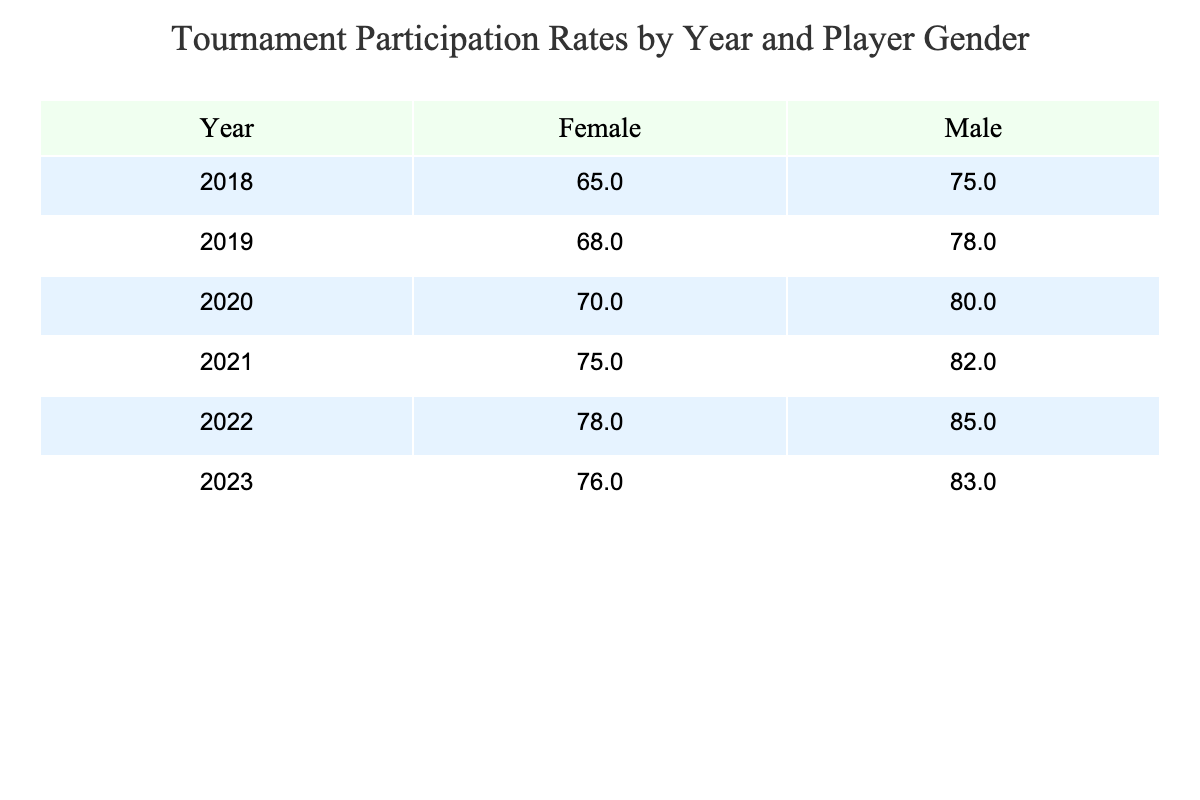What was the tournament participation rate for males in 2022? In the table, look at the row for 2022 and locate the value under the "Male" column. The participation rate for males in 2022 is 85%.
Answer: 85% What was the tournament participation rate for females in 2019? To find the answer, check the row for 2019 and look under the "Female" column. The value there indicates a participation rate of 68% for females in 2019.
Answer: 68% What is the average tournament participation rate for males from 2018 to 2023? First, gather the male participation rates from each year: 75%, 78%, 80%, 82%, 85%, and 83%. Then, sum these values: 75 + 78 + 80 + 82 + 85 + 83 = 483. Finally, divide by the number of years (6): 483 / 6 = 80.5. The average is 80.5%.
Answer: 80.5% Is the participation rate for females in 2021 higher than in 2020? Check the participation rates for females in both years. In 2020, the rate is 70%, and in 2021, it's 75%. Since 75% is greater than 70%, the statement is true.
Answer: Yes Which year had the highest tournament participation rate for females? Review the female participation rates for all years: 65%, 68%, 70%, 75%, 78%, and 76%. The highest value is 78%, which occurred in 2022.
Answer: 2022 What was the difference in tournament participation rates for males and females in 2023? For males in 2023, the participation rate is 83%, while for females, it is 76%. To find the difference, subtract the female rate from the male rate: 83 - 76 = 7. Therefore, the difference is 7%.
Answer: 7% Was the tournament participation rate for males consistently increasing from 2018 to 2023? Examine the male participation rates over the years: 75%, 78%, 80%, 82%, 85%, and 83%. While there is a general increase, note that the rate decreased from 85% in 2022 to 83% in 2023. Therefore, it was not consistently increasing.
Answer: No What was the lowest tournament participation rate for males throughout the years listed? Look through the male participation rates given: 75%, 78%, 80%, 82%, 85%, and 83%. The lowest value in this range is 75%, which occurred in 2018.
Answer: 75% 